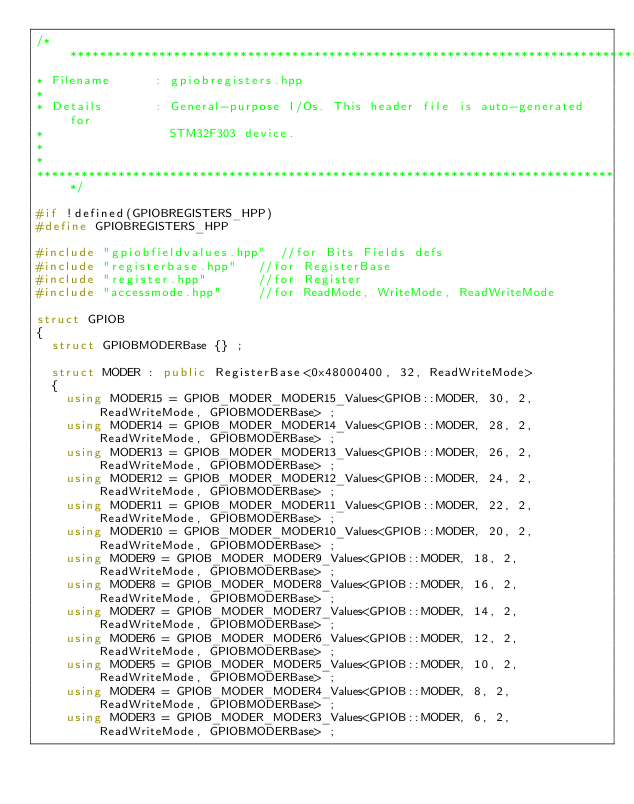Convert code to text. <code><loc_0><loc_0><loc_500><loc_500><_C++_>/*******************************************************************************
* Filename      : gpiobregisters.hpp
*
* Details       : General-purpose I/Os. This header file is auto-generated for
*                 STM32F303 device.
*
*
*******************************************************************************/

#if !defined(GPIOBREGISTERS_HPP)
#define GPIOBREGISTERS_HPP

#include "gpiobfieldvalues.hpp"  //for Bits Fields defs 
#include "registerbase.hpp"   //for RegisterBase
#include "register.hpp"       //for Register
#include "accessmode.hpp"     //for ReadMode, WriteMode, ReadWriteMode  

struct GPIOB
{
  struct GPIOBMODERBase {} ;

  struct MODER : public RegisterBase<0x48000400, 32, ReadWriteMode>
  {
    using MODER15 = GPIOB_MODER_MODER15_Values<GPIOB::MODER, 30, 2, ReadWriteMode, GPIOBMODERBase> ;
    using MODER14 = GPIOB_MODER_MODER14_Values<GPIOB::MODER, 28, 2, ReadWriteMode, GPIOBMODERBase> ;
    using MODER13 = GPIOB_MODER_MODER13_Values<GPIOB::MODER, 26, 2, ReadWriteMode, GPIOBMODERBase> ;
    using MODER12 = GPIOB_MODER_MODER12_Values<GPIOB::MODER, 24, 2, ReadWriteMode, GPIOBMODERBase> ;
    using MODER11 = GPIOB_MODER_MODER11_Values<GPIOB::MODER, 22, 2, ReadWriteMode, GPIOBMODERBase> ;
    using MODER10 = GPIOB_MODER_MODER10_Values<GPIOB::MODER, 20, 2, ReadWriteMode, GPIOBMODERBase> ;
    using MODER9 = GPIOB_MODER_MODER9_Values<GPIOB::MODER, 18, 2, ReadWriteMode, GPIOBMODERBase> ;
    using MODER8 = GPIOB_MODER_MODER8_Values<GPIOB::MODER, 16, 2, ReadWriteMode, GPIOBMODERBase> ;
    using MODER7 = GPIOB_MODER_MODER7_Values<GPIOB::MODER, 14, 2, ReadWriteMode, GPIOBMODERBase> ;
    using MODER6 = GPIOB_MODER_MODER6_Values<GPIOB::MODER, 12, 2, ReadWriteMode, GPIOBMODERBase> ;
    using MODER5 = GPIOB_MODER_MODER5_Values<GPIOB::MODER, 10, 2, ReadWriteMode, GPIOBMODERBase> ;
    using MODER4 = GPIOB_MODER_MODER4_Values<GPIOB::MODER, 8, 2, ReadWriteMode, GPIOBMODERBase> ;
    using MODER3 = GPIOB_MODER_MODER3_Values<GPIOB::MODER, 6, 2, ReadWriteMode, GPIOBMODERBase> ;</code> 